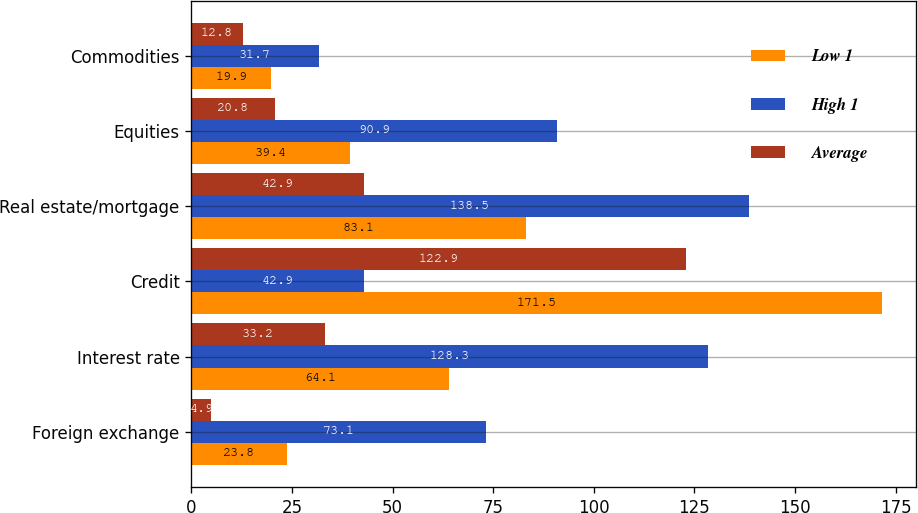Convert chart. <chart><loc_0><loc_0><loc_500><loc_500><stacked_bar_chart><ecel><fcel>Foreign exchange<fcel>Interest rate<fcel>Credit<fcel>Real estate/mortgage<fcel>Equities<fcel>Commodities<nl><fcel>Low 1<fcel>23.8<fcel>64.1<fcel>171.5<fcel>83.1<fcel>39.4<fcel>19.9<nl><fcel>High 1<fcel>73.1<fcel>128.3<fcel>42.9<fcel>138.5<fcel>90.9<fcel>31.7<nl><fcel>Average<fcel>4.9<fcel>33.2<fcel>122.9<fcel>42.9<fcel>20.8<fcel>12.8<nl></chart> 